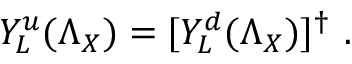<formula> <loc_0><loc_0><loc_500><loc_500>Y _ { L } ^ { u } ( \Lambda _ { X } ) = [ Y _ { L } ^ { d } ( \Lambda _ { X } ) ] ^ { \dagger } \ .</formula> 